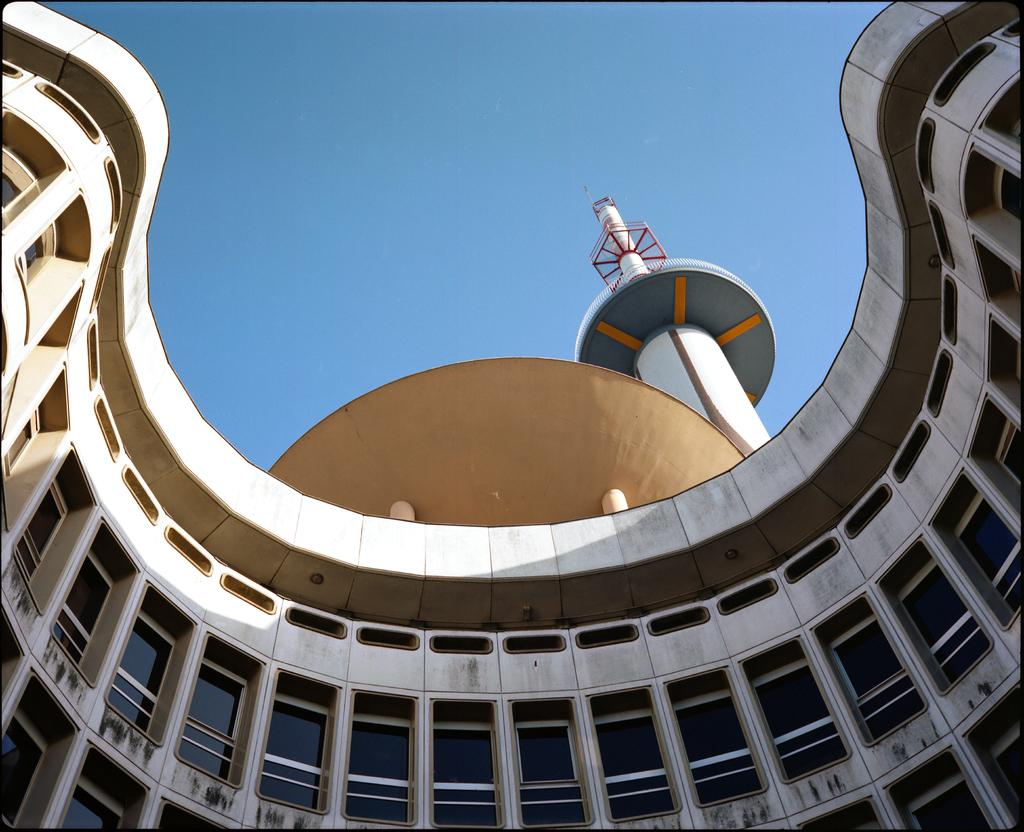What is the main subject in the front of the image? There is a building in the front of the image. What architectural feature can be seen on the building? The building has multiple windows. What can be seen in the background of the image? The sky is visible in the background of the image. How many chairs are placed in front of the building in the image? There is no mention of chairs in the image, so it is not possible to determine their presence or quantity. 